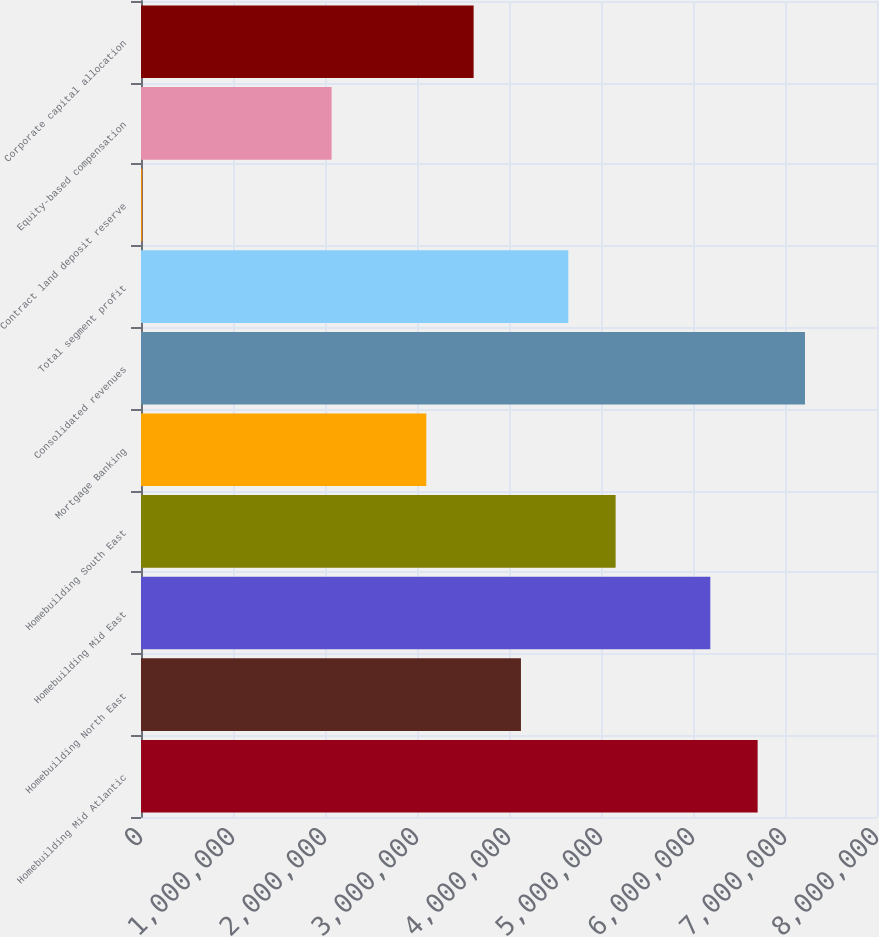Convert chart to OTSL. <chart><loc_0><loc_0><loc_500><loc_500><bar_chart><fcel>Homebuilding Mid Atlantic<fcel>Homebuilding North East<fcel>Homebuilding Mid East<fcel>Homebuilding South East<fcel>Mortgage Banking<fcel>Consolidated revenues<fcel>Total segment profit<fcel>Contract land deposit reserve<fcel>Equity-based compensation<fcel>Corporate capital allocation<nl><fcel>6.70257e+06<fcel>4.12997e+06<fcel>6.18805e+06<fcel>5.15901e+06<fcel>3.10093e+06<fcel>7.21709e+06<fcel>4.64449e+06<fcel>13805<fcel>2.07189e+06<fcel>3.61545e+06<nl></chart> 